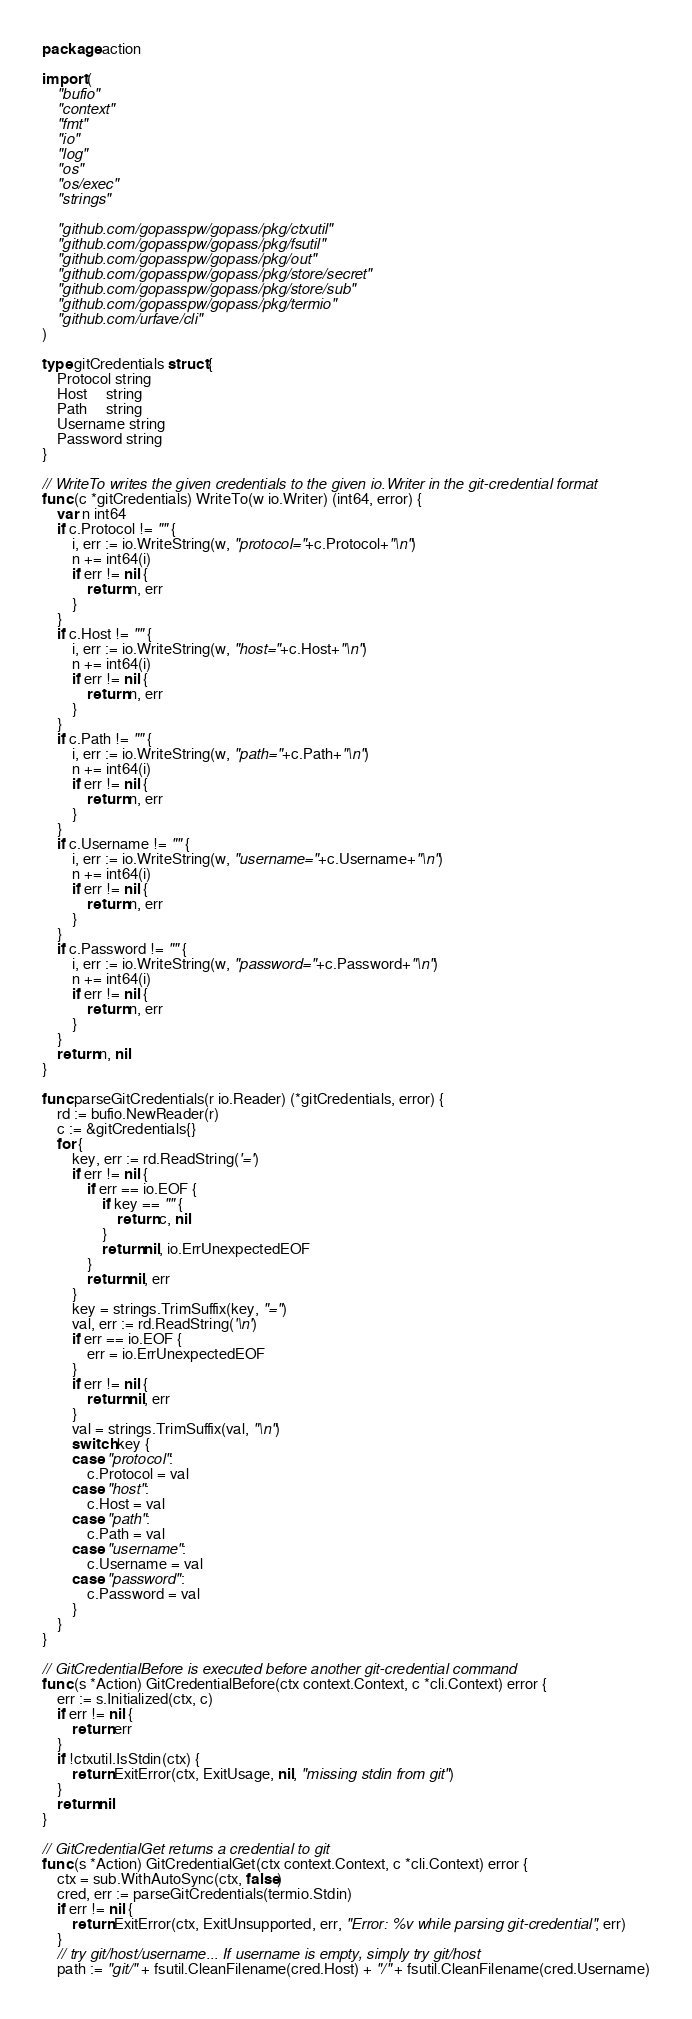Convert code to text. <code><loc_0><loc_0><loc_500><loc_500><_Go_>package action

import (
	"bufio"
	"context"
	"fmt"
	"io"
	"log"
	"os"
	"os/exec"
	"strings"

	"github.com/gopasspw/gopass/pkg/ctxutil"
	"github.com/gopasspw/gopass/pkg/fsutil"
	"github.com/gopasspw/gopass/pkg/out"
	"github.com/gopasspw/gopass/pkg/store/secret"
	"github.com/gopasspw/gopass/pkg/store/sub"
	"github.com/gopasspw/gopass/pkg/termio"
	"github.com/urfave/cli"
)

type gitCredentials struct {
	Protocol string
	Host     string
	Path     string
	Username string
	Password string
}

// WriteTo writes the given credentials to the given io.Writer in the git-credential format
func (c *gitCredentials) WriteTo(w io.Writer) (int64, error) {
	var n int64
	if c.Protocol != "" {
		i, err := io.WriteString(w, "protocol="+c.Protocol+"\n")
		n += int64(i)
		if err != nil {
			return n, err
		}
	}
	if c.Host != "" {
		i, err := io.WriteString(w, "host="+c.Host+"\n")
		n += int64(i)
		if err != nil {
			return n, err
		}
	}
	if c.Path != "" {
		i, err := io.WriteString(w, "path="+c.Path+"\n")
		n += int64(i)
		if err != nil {
			return n, err
		}
	}
	if c.Username != "" {
		i, err := io.WriteString(w, "username="+c.Username+"\n")
		n += int64(i)
		if err != nil {
			return n, err
		}
	}
	if c.Password != "" {
		i, err := io.WriteString(w, "password="+c.Password+"\n")
		n += int64(i)
		if err != nil {
			return n, err
		}
	}
	return n, nil
}

func parseGitCredentials(r io.Reader) (*gitCredentials, error) {
	rd := bufio.NewReader(r)
	c := &gitCredentials{}
	for {
		key, err := rd.ReadString('=')
		if err != nil {
			if err == io.EOF {
				if key == "" {
					return c, nil
				}
				return nil, io.ErrUnexpectedEOF
			}
			return nil, err
		}
		key = strings.TrimSuffix(key, "=")
		val, err := rd.ReadString('\n')
		if err == io.EOF {
			err = io.ErrUnexpectedEOF
		}
		if err != nil {
			return nil, err
		}
		val = strings.TrimSuffix(val, "\n")
		switch key {
		case "protocol":
			c.Protocol = val
		case "host":
			c.Host = val
		case "path":
			c.Path = val
		case "username":
			c.Username = val
		case "password":
			c.Password = val
		}
	}
}

// GitCredentialBefore is executed before another git-credential command
func (s *Action) GitCredentialBefore(ctx context.Context, c *cli.Context) error {
	err := s.Initialized(ctx, c)
	if err != nil {
		return err
	}
	if !ctxutil.IsStdin(ctx) {
		return ExitError(ctx, ExitUsage, nil, "missing stdin from git")
	}
	return nil
}

// GitCredentialGet returns a credential to git
func (s *Action) GitCredentialGet(ctx context.Context, c *cli.Context) error {
	ctx = sub.WithAutoSync(ctx, false)
	cred, err := parseGitCredentials(termio.Stdin)
	if err != nil {
		return ExitError(ctx, ExitUnsupported, err, "Error: %v while parsing git-credential", err)
	}
	// try git/host/username... If username is empty, simply try git/host
	path := "git/" + fsutil.CleanFilename(cred.Host) + "/" + fsutil.CleanFilename(cred.Username)</code> 